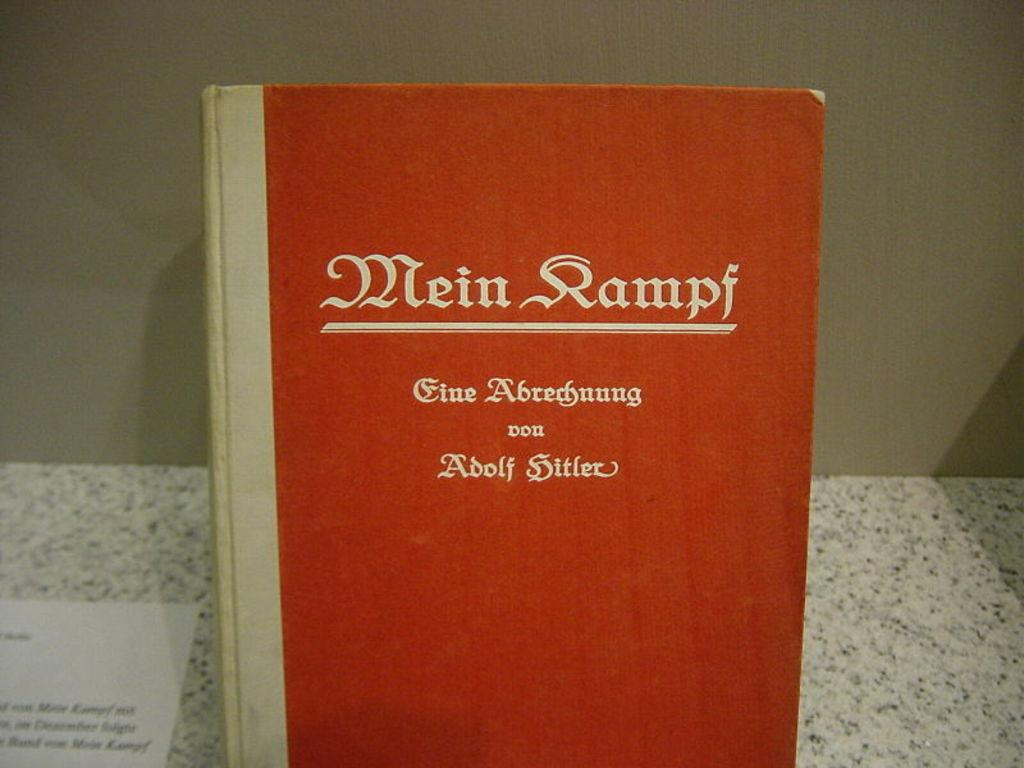<image>
Relay a brief, clear account of the picture shown. a hardback issue of mein kampf written by adolf Hitler. 